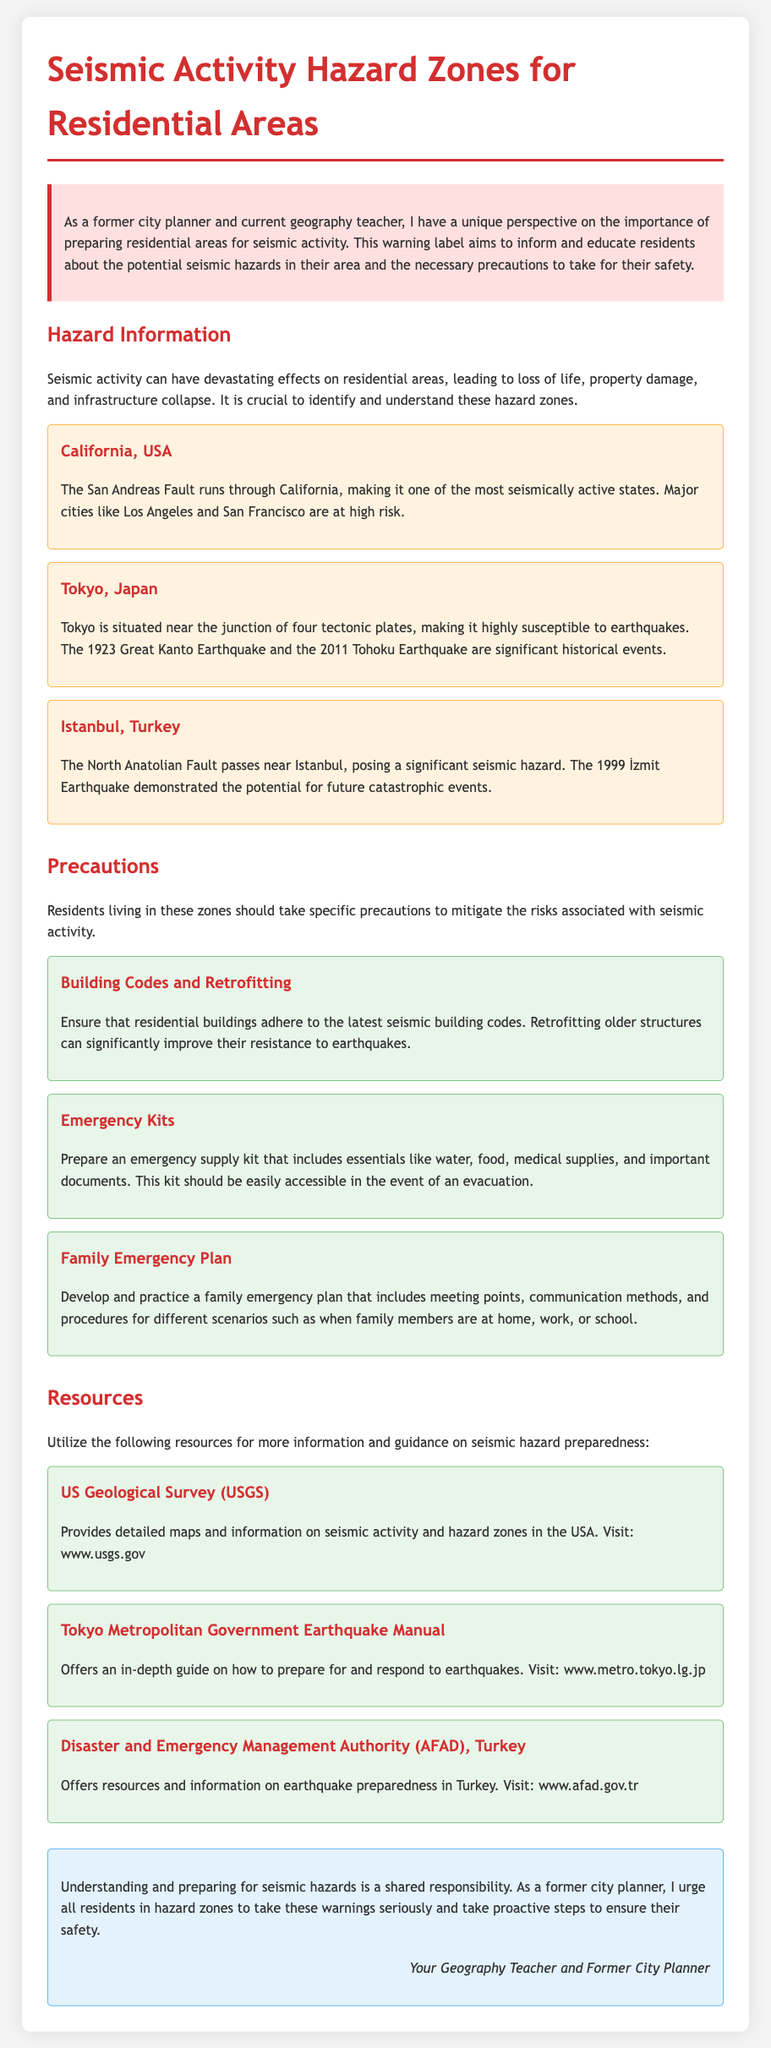What is the title of the document? The title is stated at the top of the document as "Seismic Activity Hazard Zones for Residential Areas."
Answer: Seismic Activity Hazard Zones for Residential Areas Which fault runs through California? The document mentions the San Andreas Fault as running through California.
Answer: San Andreas Fault What year did the Great Kanto Earthquake occur? The document lists 1923 as the year of the Great Kanto Earthquake.
Answer: 1923 What should residents prepare for emergencies? The document suggests preparing an emergency supply kit.
Answer: Emergency supply kit How many tectonic plates is Tokyo situated near? According to the document, Tokyo is situated near four tectonic plates.
Answer: Four What is one precaution for building safety? The document mentions ensuring that residential buildings adhere to the latest seismic building codes.
Answer: Latest seismic building codes What organization provides maps and information on seismic activity in the USA? The document states that the US Geological Survey provides this information.
Answer: US Geological Survey What is a key element of a family emergency plan? The document emphasizes developing and practicing meeting points as a key element.
Answer: Meeting points 